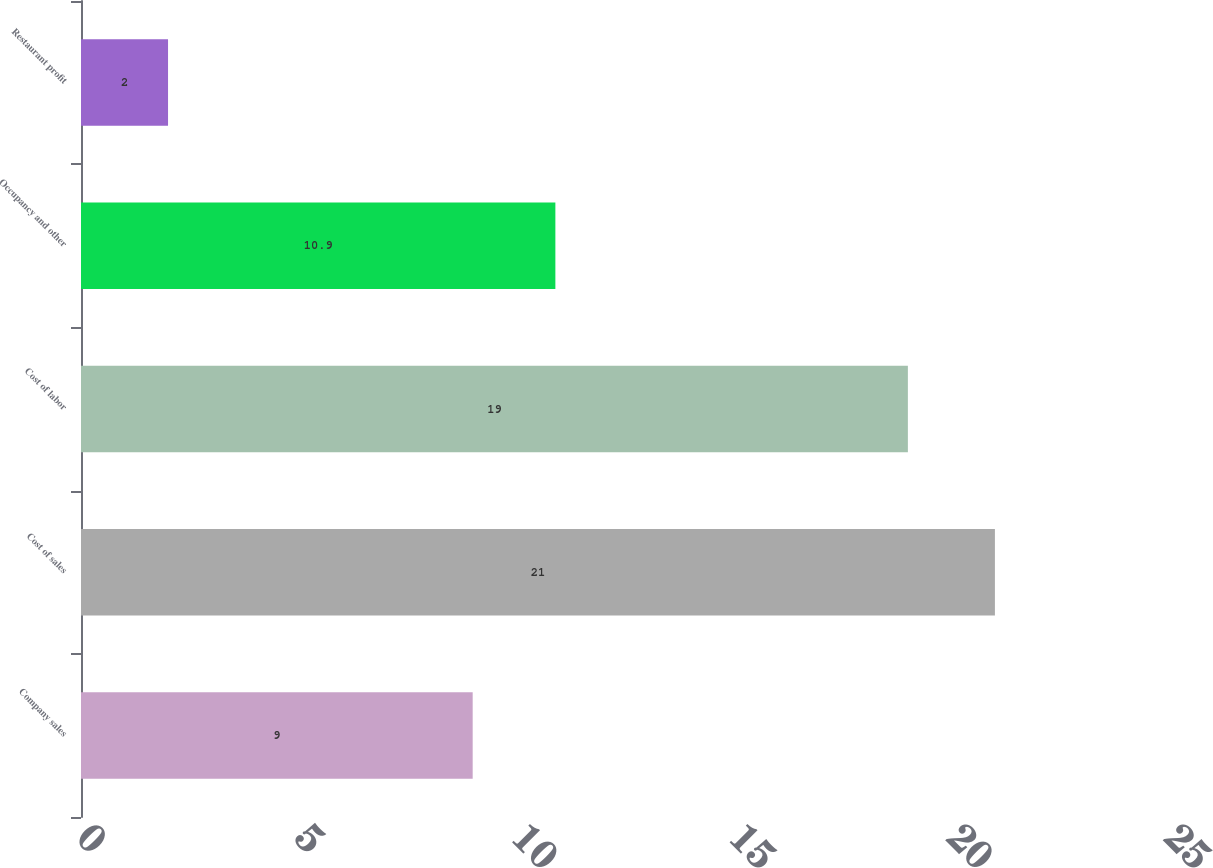Convert chart to OTSL. <chart><loc_0><loc_0><loc_500><loc_500><bar_chart><fcel>Company sales<fcel>Cost of sales<fcel>Cost of labor<fcel>Occupancy and other<fcel>Restaurant profit<nl><fcel>9<fcel>21<fcel>19<fcel>10.9<fcel>2<nl></chart> 